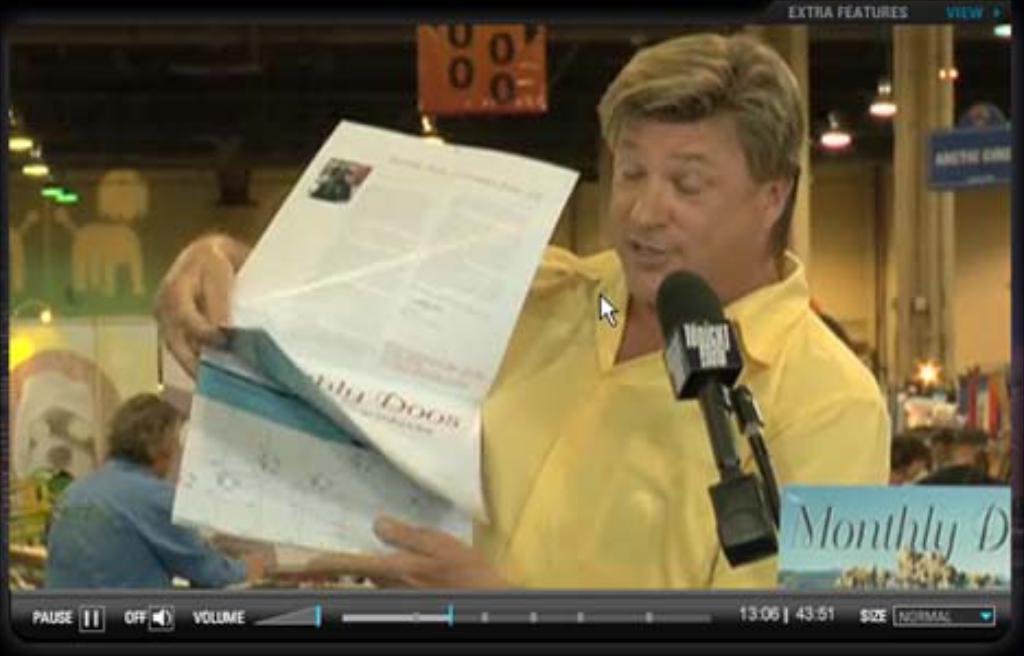Can you describe this image briefly? In the picture we can see a video screen with a man sitting and holding a newspaper and behind him we can see a man sitting and to the ceiling we can see the lights and a pillar. 